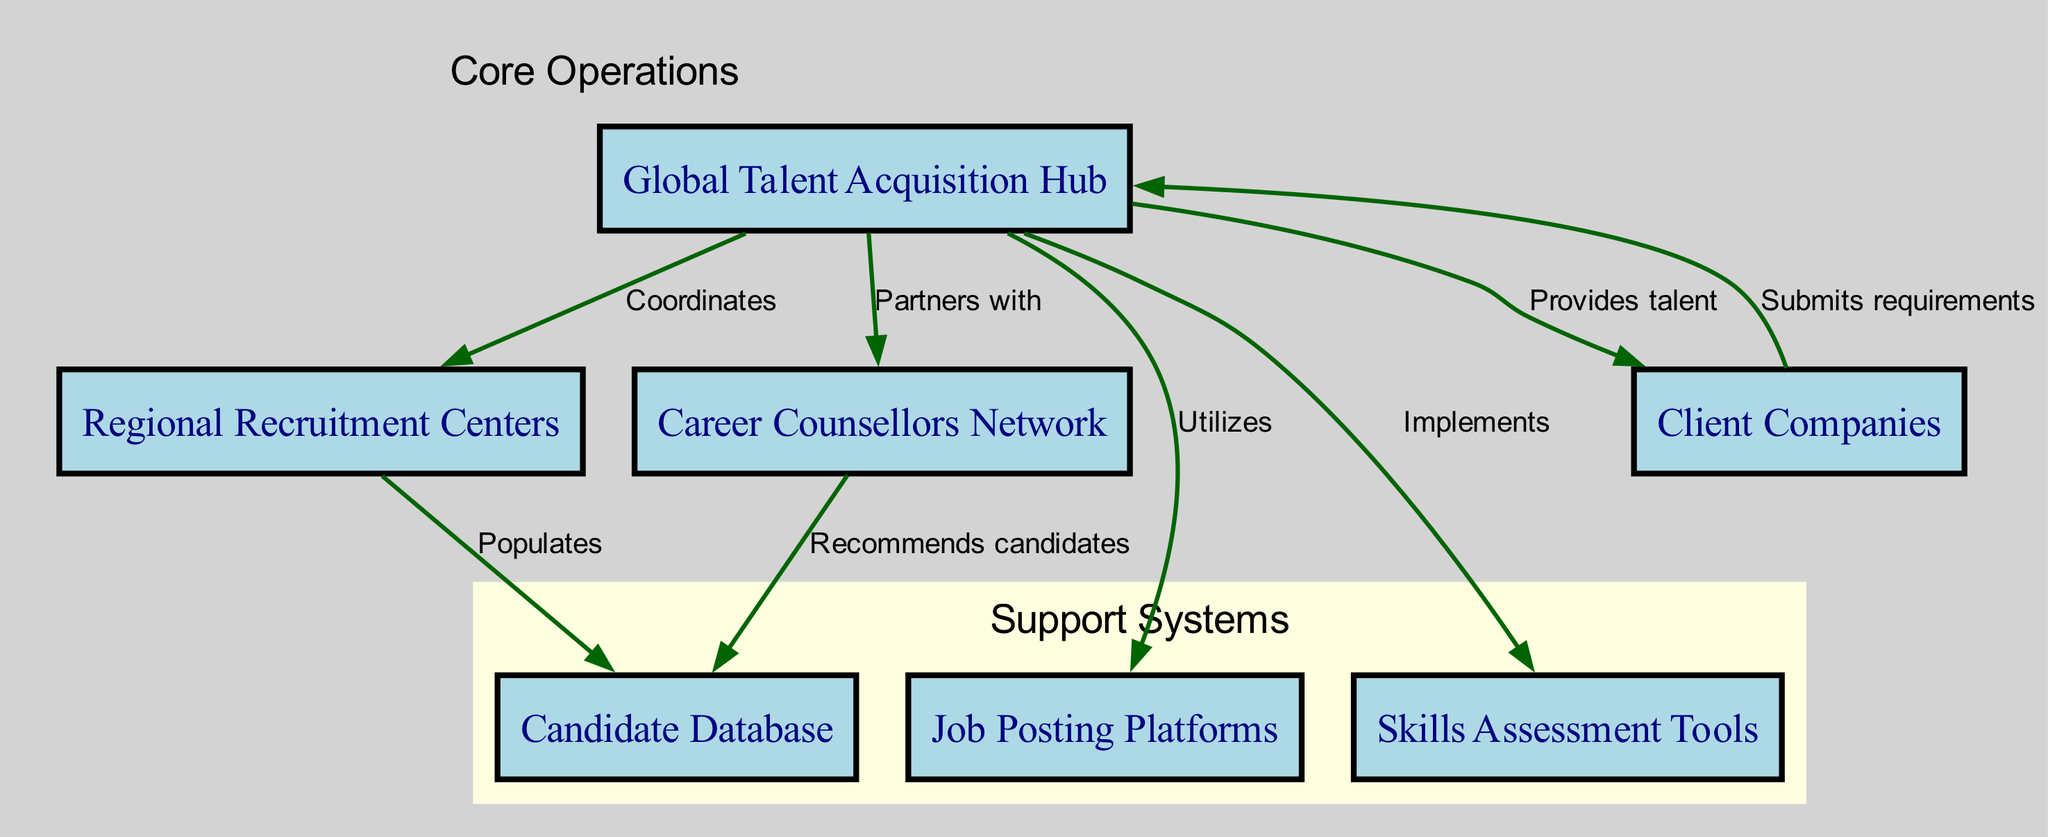What is the central component of the diagram? The central component of the diagram is identified as the "Global Talent Acquisition Hub," which is the main node connecting various elements of the talent acquisition network.
Answer: Global Talent Acquisition Hub How many nodes are present in the diagram? By counting the entries listed under the "nodes" section, we find that there are 7 distinct components in the diagram.
Answer: 7 Which entity is responsible for recommending candidates to the Candidate Database? The "Career Counsellors Network" is the entity that has an edge labeled "Recommends candidates," indicating it recommends candidates to the Candidate Database.
Answer: Career Counsellors Network What do Client Companies submit to the Global Talent Acquisition Hub? The edge labeled "Submits requirements" indicates that Client Companies provide job requirements to the Global Talent Acquisition Hub, highlighting their role in the network.
Answer: Requirements Which components are categorized under Support Systems? The components classified under Support Systems, specified in the diagram, include "Candidate Database," "Job Posting Platforms," and "Skills Assessment Tools."
Answer: Candidate Database, Job Posting Platforms, Skills Assessment Tools How does the Global Talent Acquisition Hub interact with Regional Recruitment Centers? The edge connecting the Global Talent Acquisition Hub to Regional Recruitment Centers is labeled "Coordinates," indicating a collaborative coordination between these two elements in the talent acquisition process.
Answer: Coordinates Which component utilizes Job Posting Platforms? The "Global Talent Acquisition Hub" is labeled as the component that "Utilizes" Job Posting Platforms, indicating its role in leveraging these platforms for talent acquisition.
Answer: Global Talent Acquisition Hub What are the two roles of the Global Talent Acquisition Hub related to Client Companies? The Global Talent Acquisition Hub has two roles labeled "Submits requirements" and "Provides talent," showing its dual function in both receiving requests and supplying candidates.
Answer: Submits requirements, Provides talent 